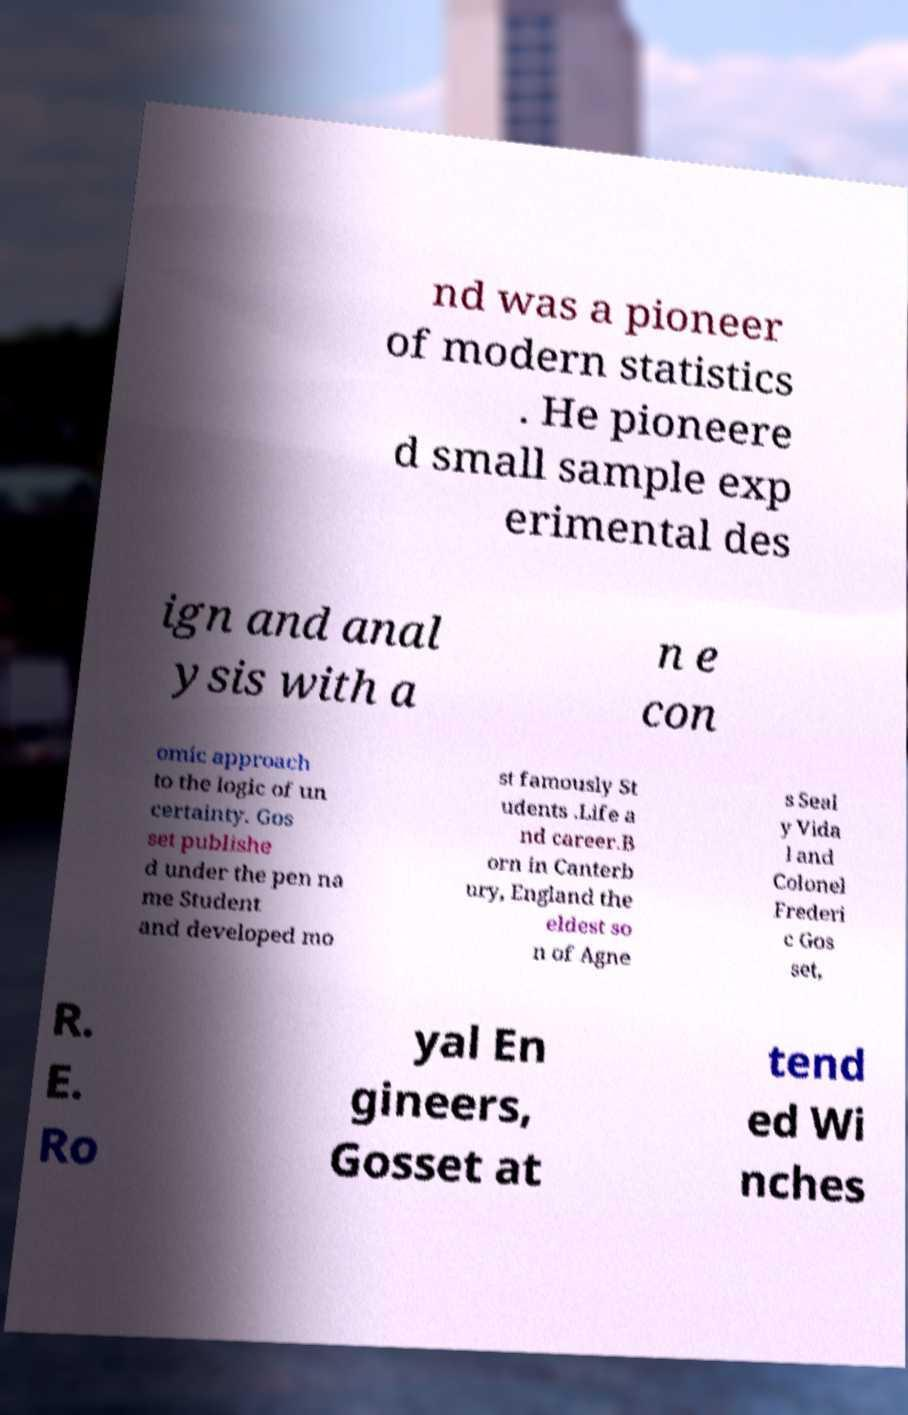Can you accurately transcribe the text from the provided image for me? nd was a pioneer of modern statistics . He pioneere d small sample exp erimental des ign and anal ysis with a n e con omic approach to the logic of un certainty. Gos set publishe d under the pen na me Student and developed mo st famously St udents .Life a nd career.B orn in Canterb ury, England the eldest so n of Agne s Seal y Vida l and Colonel Frederi c Gos set, R. E. Ro yal En gineers, Gosset at tend ed Wi nches 